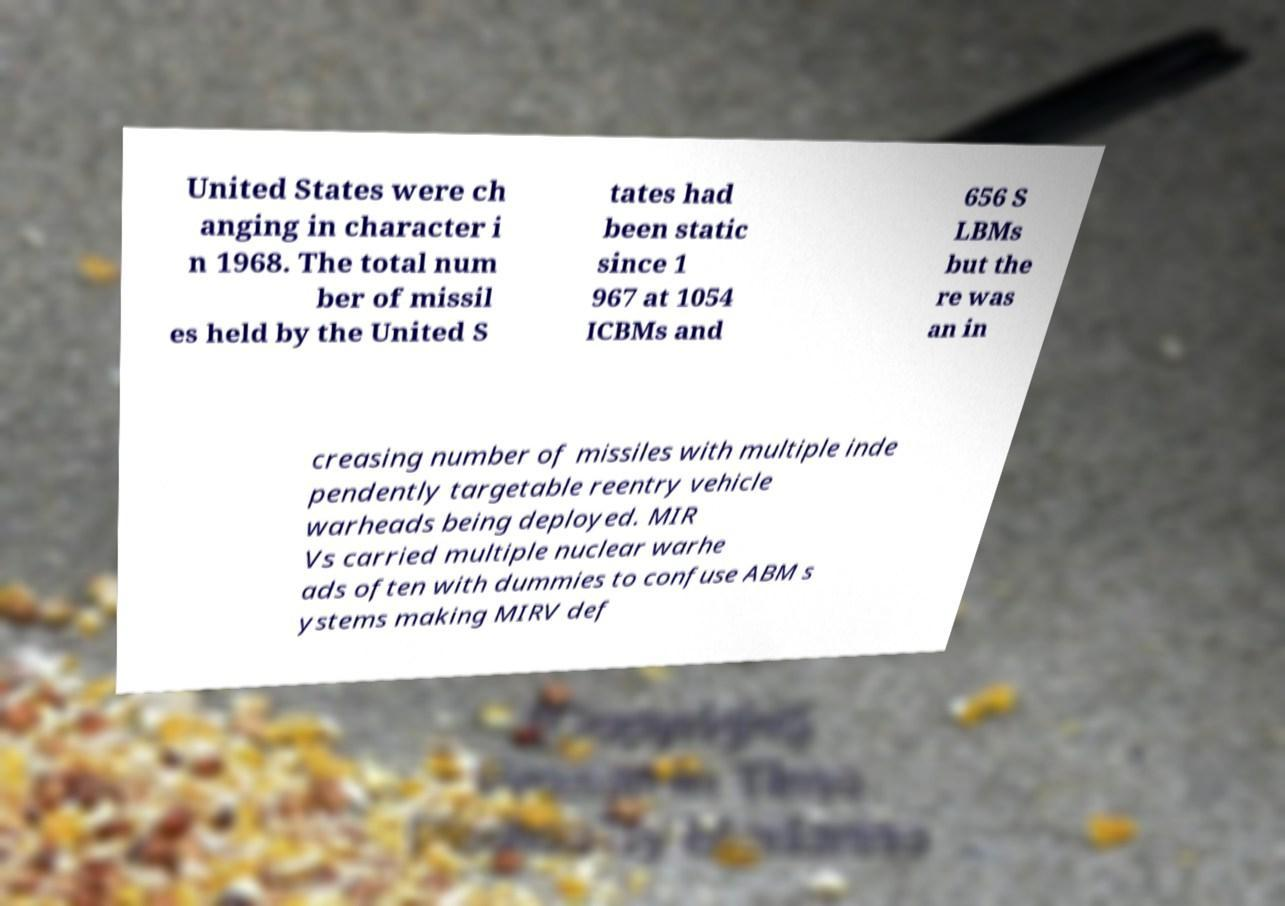There's text embedded in this image that I need extracted. Can you transcribe it verbatim? United States were ch anging in character i n 1968. The total num ber of missil es held by the United S tates had been static since 1 967 at 1054 ICBMs and 656 S LBMs but the re was an in creasing number of missiles with multiple inde pendently targetable reentry vehicle warheads being deployed. MIR Vs carried multiple nuclear warhe ads often with dummies to confuse ABM s ystems making MIRV def 